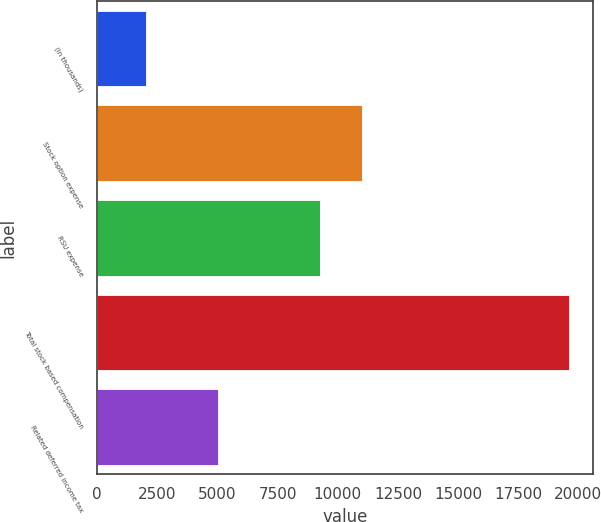<chart> <loc_0><loc_0><loc_500><loc_500><bar_chart><fcel>(in thousands)<fcel>Stock option expense<fcel>RSU expense<fcel>Total stock based compensation<fcel>Related deferred income tax<nl><fcel>2011<fcel>11003.1<fcel>9243<fcel>19612<fcel>5021<nl></chart> 